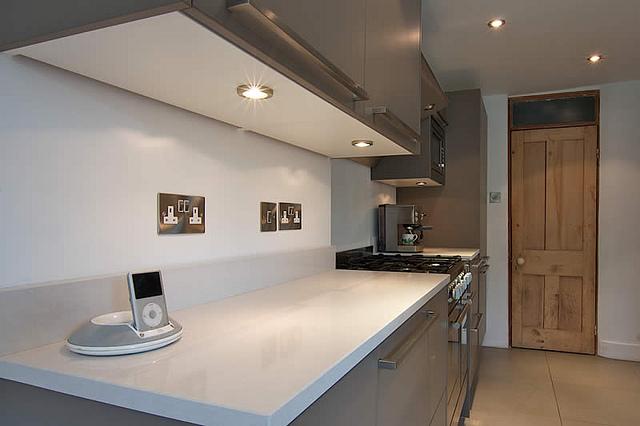Is it a gas or electric stove?
Keep it brief. Gas. Does this house run on gas?
Keep it brief. Yes. What is this in the picture?
Quick response, please. Ipod. Where is the iPod?
Answer briefly. On counter. What is on the counter?
Be succinct. Ipod. 